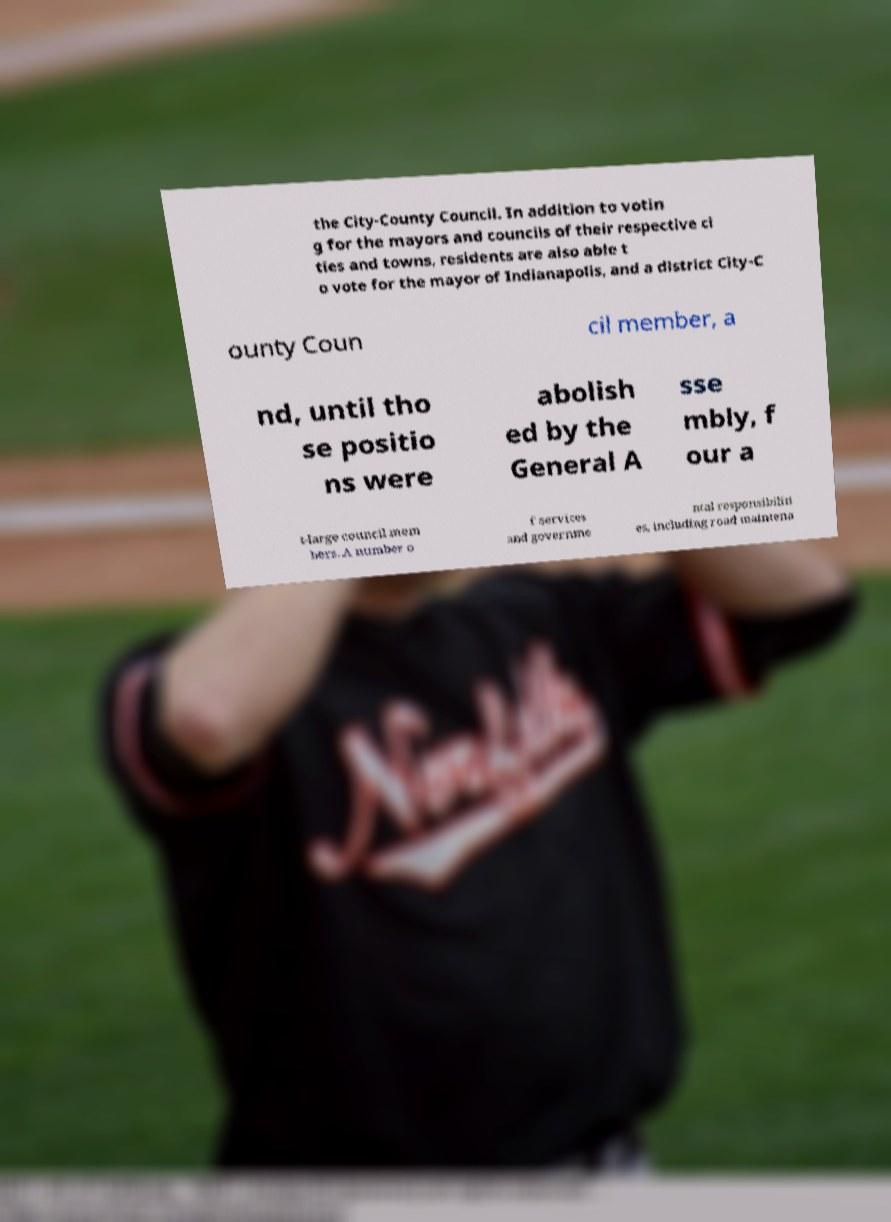Please read and relay the text visible in this image. What does it say? the City-County Council. In addition to votin g for the mayors and councils of their respective ci ties and towns, residents are also able t o vote for the mayor of Indianapolis, and a district City-C ounty Coun cil member, a nd, until tho se positio ns were abolish ed by the General A sse mbly, f our a t-large council mem bers. A number o f services and governme ntal responsibiliti es, including road maintena 